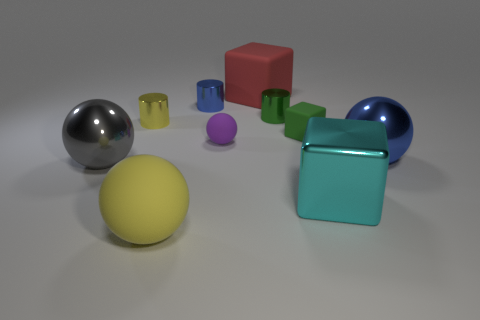There is a shiny object that is the same color as the tiny rubber block; what is its shape?
Ensure brevity in your answer.  Cylinder. How many things are either big metal balls that are right of the metal cube or large things that are in front of the red rubber object?
Give a very brief answer. 4. Are there fewer small purple spheres than small purple cylinders?
Keep it short and to the point. No. What number of objects are either small blue metal cubes or tiny green matte things?
Your response must be concise. 1. Is the shape of the green metal object the same as the tiny yellow object?
Offer a very short reply. Yes. Are there any other things that have the same material as the large cyan cube?
Keep it short and to the point. Yes. There is a blue shiny object to the left of the large blue metallic object; does it have the same size as the matte object in front of the cyan shiny object?
Provide a short and direct response. No. There is a thing that is in front of the blue ball and on the right side of the big red matte block; what material is it?
Your answer should be compact. Metal. Are there any other things that are the same color as the tiny ball?
Provide a short and direct response. No. Is the number of big shiny spheres to the left of the shiny cube less than the number of green metallic things?
Your answer should be compact. No. 